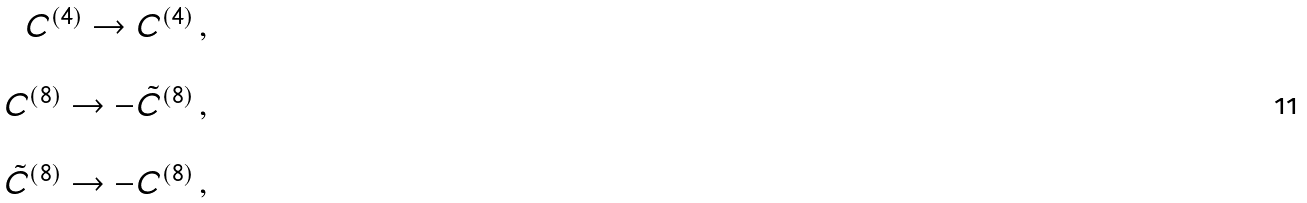Convert formula to latex. <formula><loc_0><loc_0><loc_500><loc_500>\begin{array} { r c l } C ^ { ( 4 ) } \rightarrow C ^ { ( 4 ) } \, , \\ & & \\ C ^ { ( 8 ) } \rightarrow - { \tilde { C } } ^ { ( 8 ) } \, , \\ & & \\ { \tilde { C } } ^ { ( 8 ) } \rightarrow - C ^ { ( 8 ) } \, , \\ \end{array}</formula> 